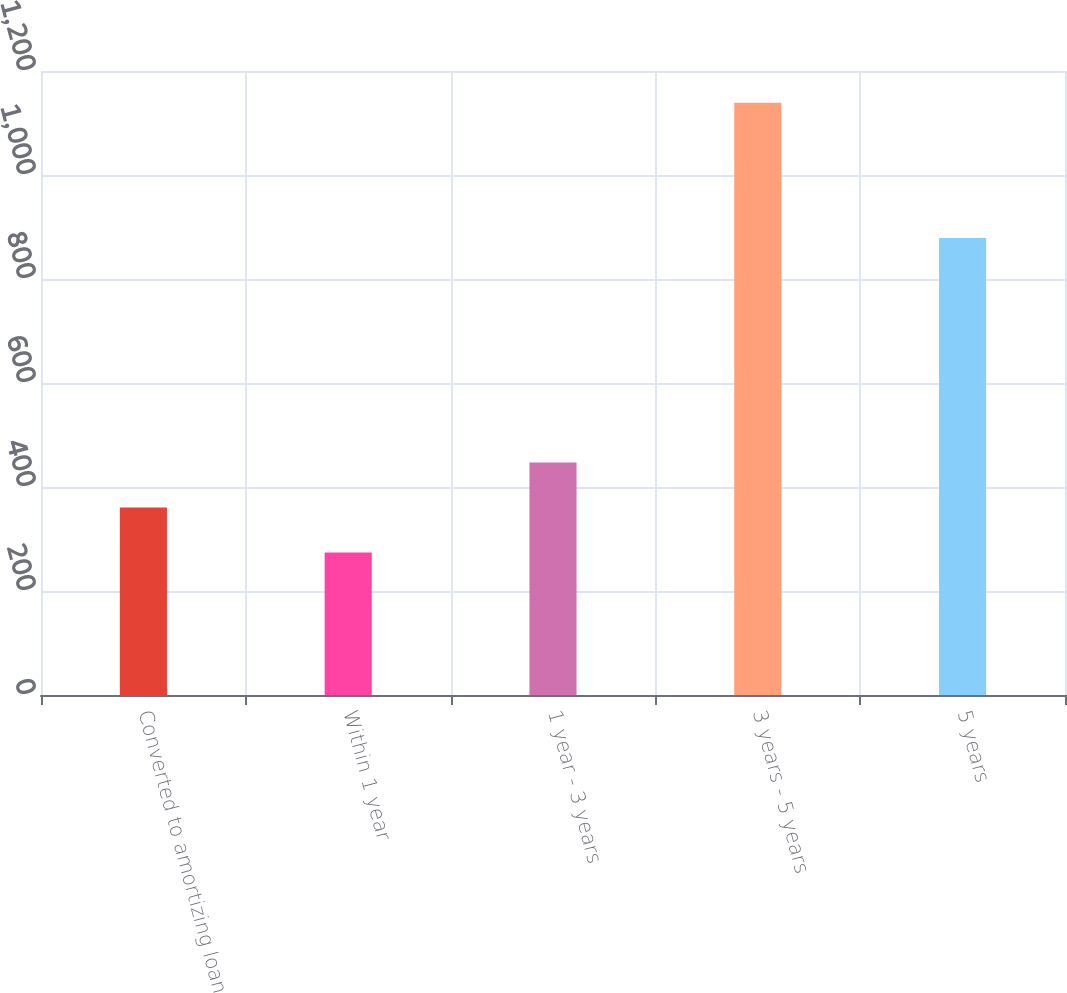Convert chart. <chart><loc_0><loc_0><loc_500><loc_500><bar_chart><fcel>Converted to amortizing loan<fcel>Within 1 year<fcel>1 year - 3 years<fcel>3 years - 5 years<fcel>5 years<nl><fcel>360.5<fcel>274<fcel>447<fcel>1139<fcel>879<nl></chart> 